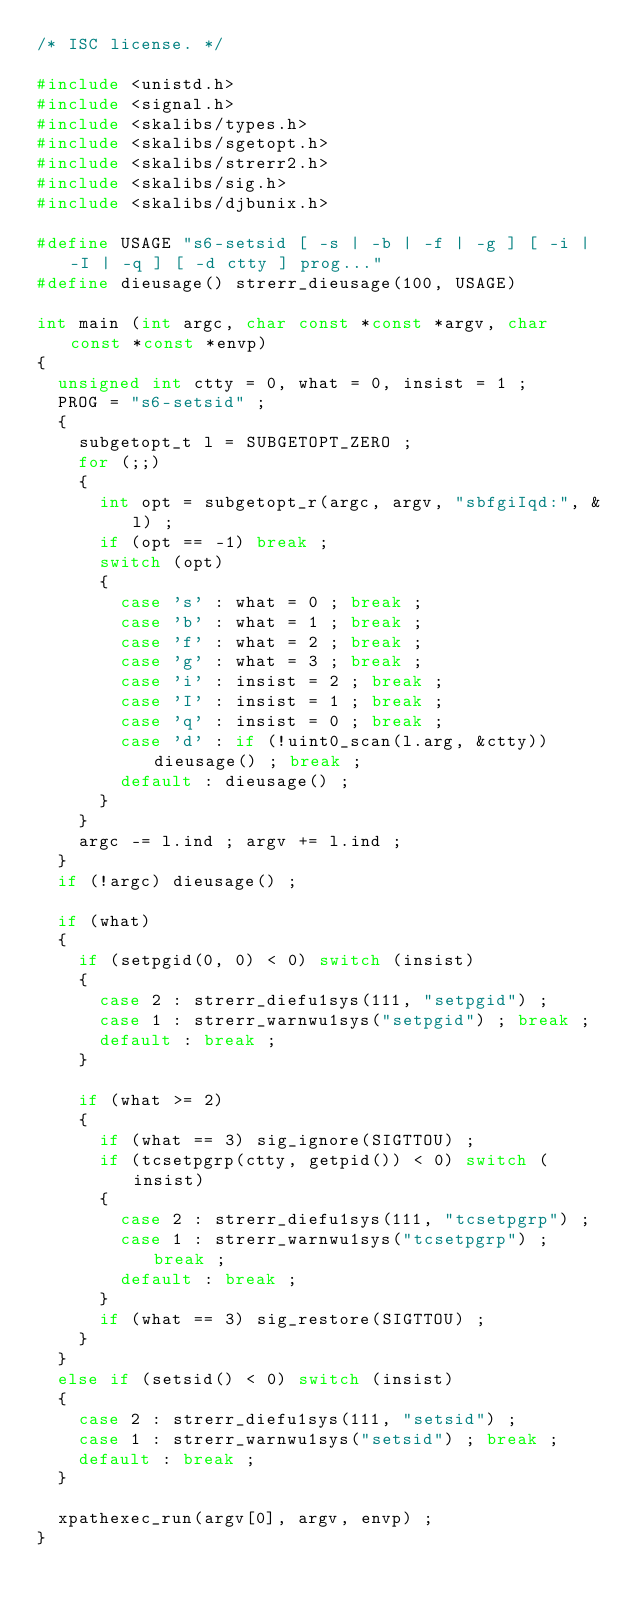Convert code to text. <code><loc_0><loc_0><loc_500><loc_500><_C_>/* ISC license. */

#include <unistd.h>
#include <signal.h>
#include <skalibs/types.h>
#include <skalibs/sgetopt.h>
#include <skalibs/strerr2.h>
#include <skalibs/sig.h>
#include <skalibs/djbunix.h>

#define USAGE "s6-setsid [ -s | -b | -f | -g ] [ -i | -I | -q ] [ -d ctty ] prog..."
#define dieusage() strerr_dieusage(100, USAGE)

int main (int argc, char const *const *argv, char const *const *envp)
{
  unsigned int ctty = 0, what = 0, insist = 1 ;
  PROG = "s6-setsid" ;
  {
    subgetopt_t l = SUBGETOPT_ZERO ;
    for (;;)
    {
      int opt = subgetopt_r(argc, argv, "sbfgiIqd:", &l) ;
      if (opt == -1) break ;
      switch (opt)
      {
        case 's' : what = 0 ; break ;
        case 'b' : what = 1 ; break ;
        case 'f' : what = 2 ; break ;
        case 'g' : what = 3 ; break ;
        case 'i' : insist = 2 ; break ;
        case 'I' : insist = 1 ; break ;
        case 'q' : insist = 0 ; break ;
        case 'd' : if (!uint0_scan(l.arg, &ctty)) dieusage() ; break ;
        default : dieusage() ;
      }
    }
    argc -= l.ind ; argv += l.ind ;
  }
  if (!argc) dieusage() ;

  if (what)
  {
    if (setpgid(0, 0) < 0) switch (insist)
    {
      case 2 : strerr_diefu1sys(111, "setpgid") ;
      case 1 : strerr_warnwu1sys("setpgid") ; break ;
      default : break ;
    }

    if (what >= 2)
    {
      if (what == 3) sig_ignore(SIGTTOU) ;
      if (tcsetpgrp(ctty, getpid()) < 0) switch (insist)
      {
        case 2 : strerr_diefu1sys(111, "tcsetpgrp") ;
        case 1 : strerr_warnwu1sys("tcsetpgrp") ; break ;
        default : break ;
      }
      if (what == 3) sig_restore(SIGTTOU) ;
    }
  }
  else if (setsid() < 0) switch (insist)
  {
    case 2 : strerr_diefu1sys(111, "setsid") ;
    case 1 : strerr_warnwu1sys("setsid") ; break ;
    default : break ;
  }

  xpathexec_run(argv[0], argv, envp) ;
}
</code> 